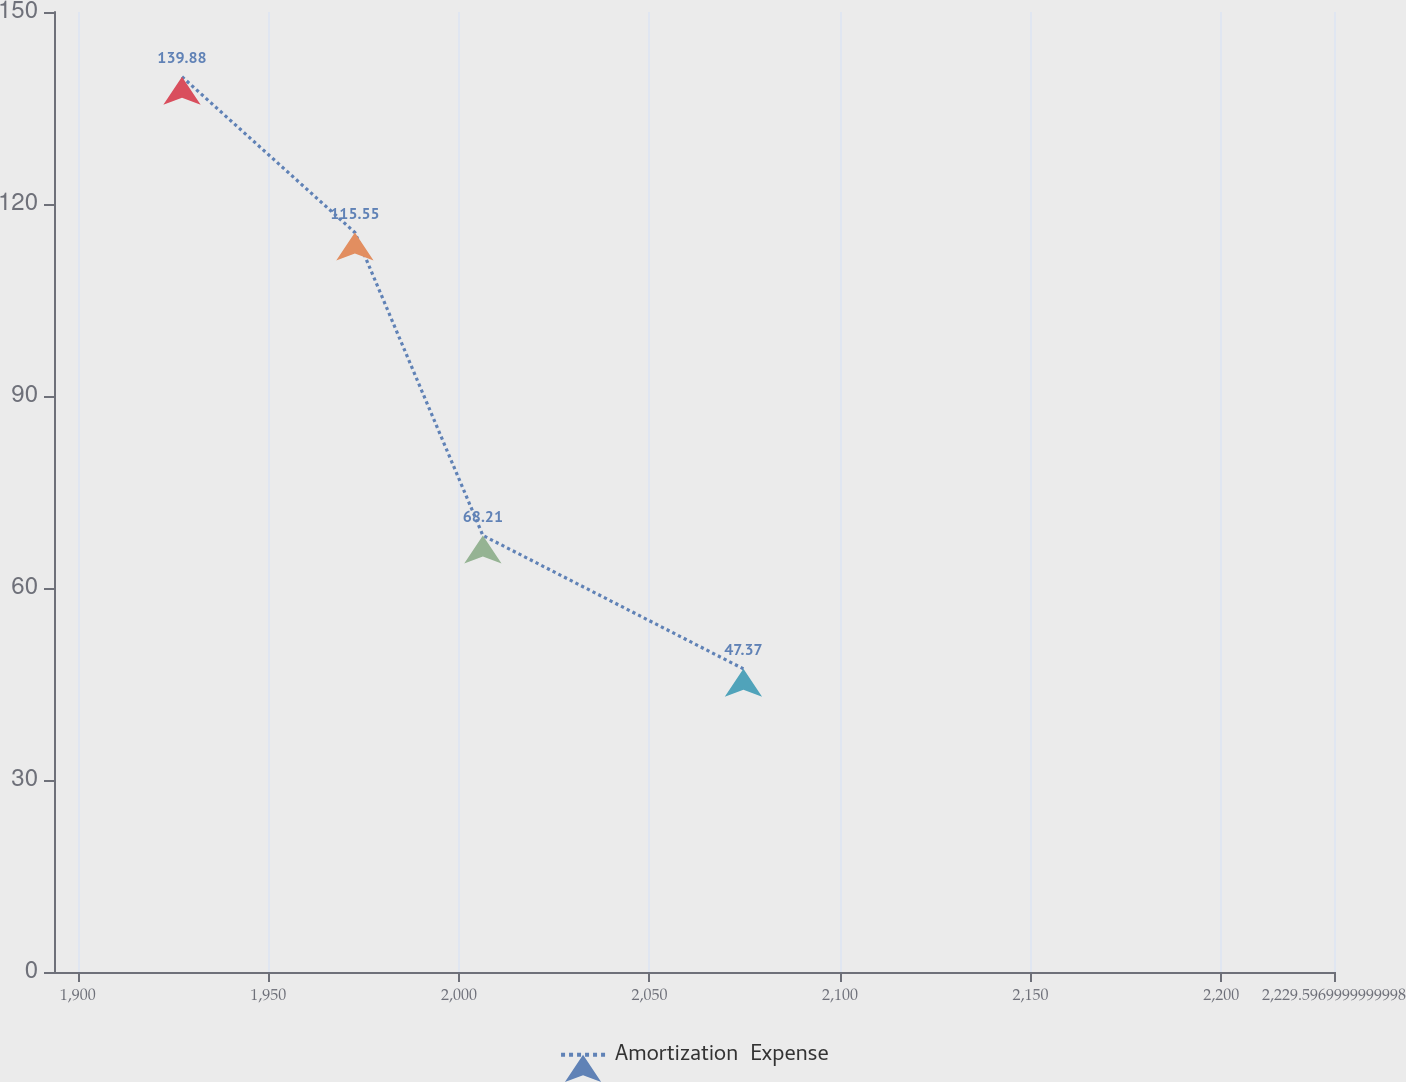<chart> <loc_0><loc_0><loc_500><loc_500><line_chart><ecel><fcel>Amortization  Expense<nl><fcel>1927.35<fcel>139.88<nl><fcel>1972.71<fcel>115.55<nl><fcel>2006.29<fcel>68.21<nl><fcel>2074.65<fcel>47.37<nl><fcel>2263.18<fcel>58.96<nl></chart> 